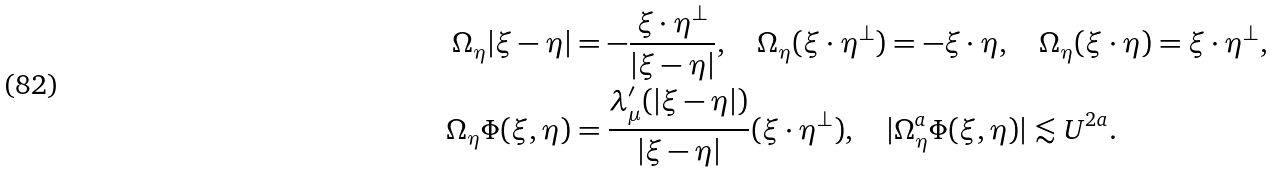<formula> <loc_0><loc_0><loc_500><loc_500>\Omega _ { \eta } | \xi - \eta | & = - \frac { \xi \cdot \eta ^ { \perp } } { | \xi - \eta | } , \quad \Omega _ { \eta } ( \xi \cdot \eta ^ { \perp } ) = - \xi \cdot \eta , \quad \Omega _ { \eta } ( \xi \cdot \eta ) = \xi \cdot \eta ^ { \perp } , \\ \Omega _ { \eta } \Phi ( \xi , \eta ) & = \frac { \lambda ^ { \prime } _ { \mu } ( | \xi - \eta | ) } { | \xi - \eta | } ( \xi \cdot \eta ^ { \perp } ) , \quad | \Omega _ { \eta } ^ { a } \Phi ( \xi , \eta ) | \lesssim U ^ { 2 a } .</formula> 